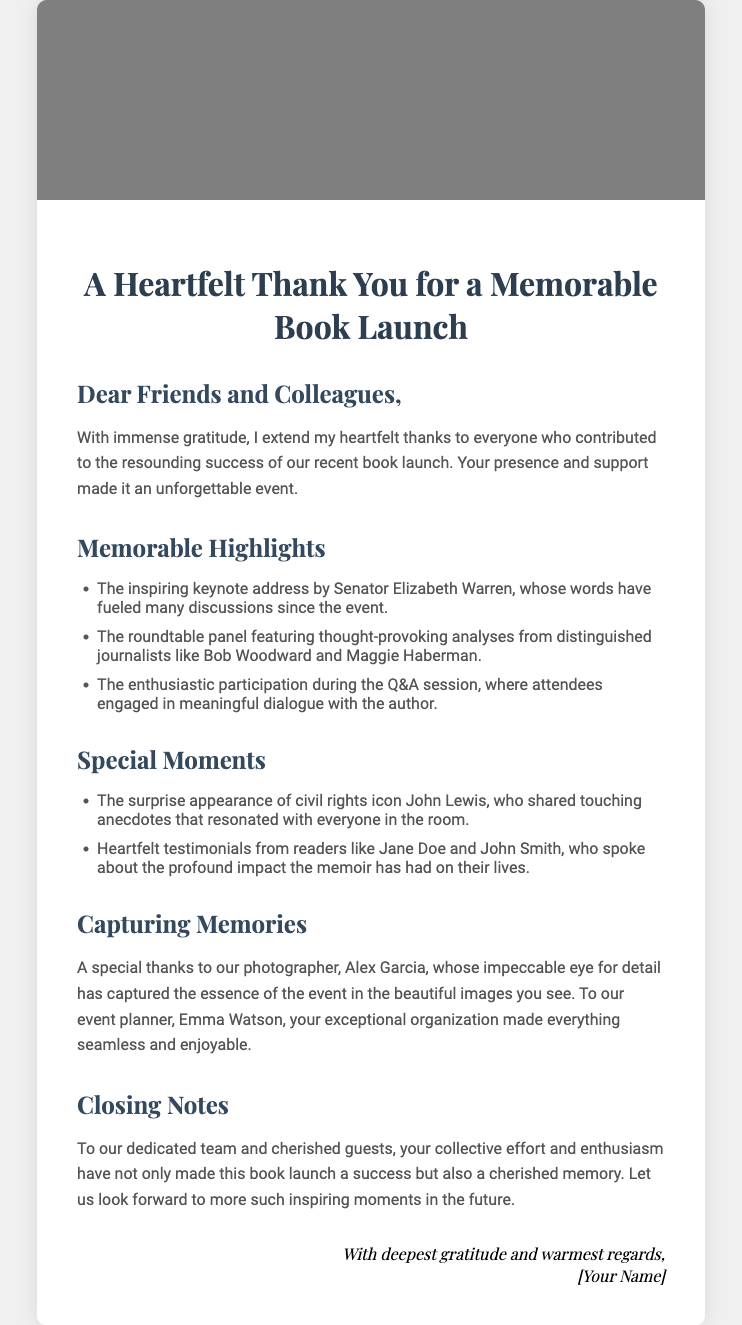what is the title of the card? The title is prominently displayed at the top of the card, summarizing the intention of the note.
Answer: A Heartfelt Thank You for a Memorable Book Launch who delivered the keynote address at the launch? The document specifies the person who gave the keynote address as part of the memorable highlights section.
Answer: Senator Elizabeth Warren what was captured by the photographer? The card mentions the role of the photographer in memorializing the event's essence, reflecting their contributions.
Answer: Beautiful images which civil rights icon made a surprise appearance? The document highlights a special moment during the event that includes a notable figure.
Answer: John Lewis how did the attendees engage with the author during the event? The card describes how audience participation occurred, indicating the nature of interaction during a specific segment.
Answer: Q&A session what is mentioned about Emma Watson in the card? The text acknowledges a particular individual for their role in organizing the event effectively.
Answer: Event planner how did the author feel about the gathered guests? The closing note conveys the author's emotions toward those who attended the launch.
Answer: Cherished memory what does the author express gratitude for in the closing notes? The document's conclusion summarizes the author's appreciation towards the collective effort that led to the event's success.
Answer: Support and enthusiasm 